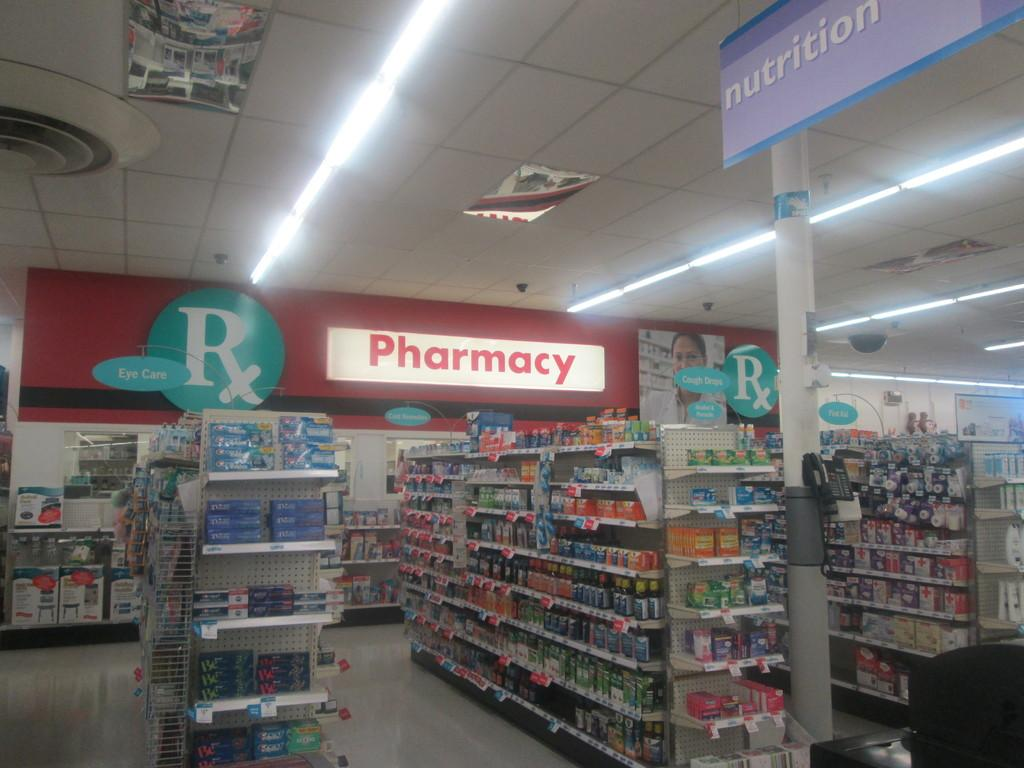<image>
Offer a succinct explanation of the picture presented. The Pharmacy section of a store with cough drops and eye care. 